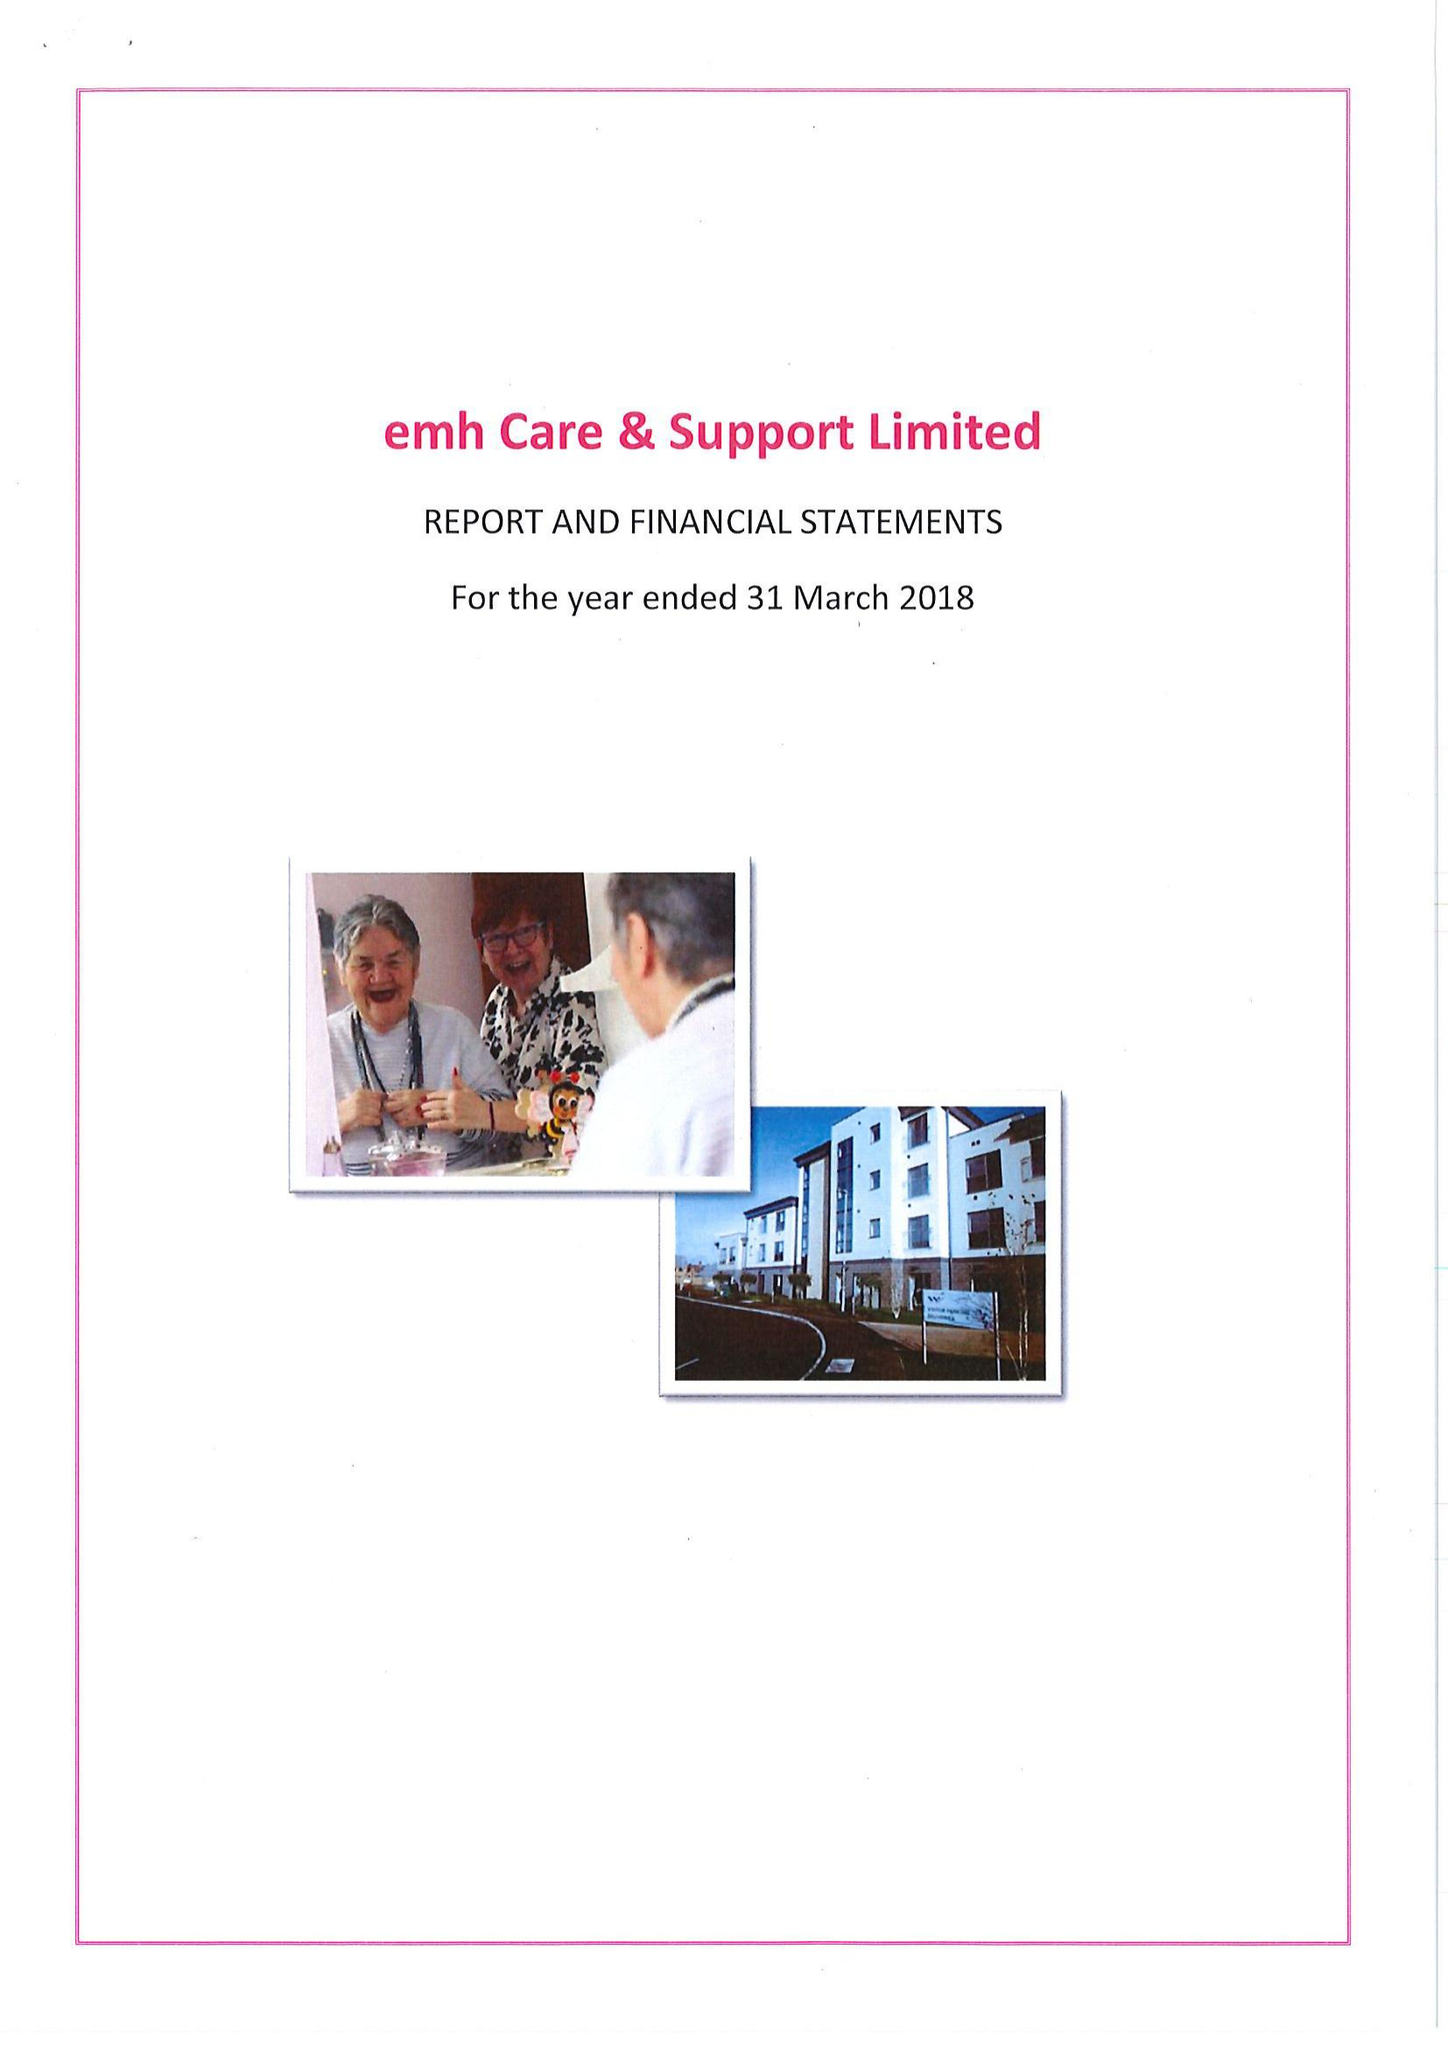What is the value for the address__postcode?
Answer the question using a single word or phrase. LE67 4JP 